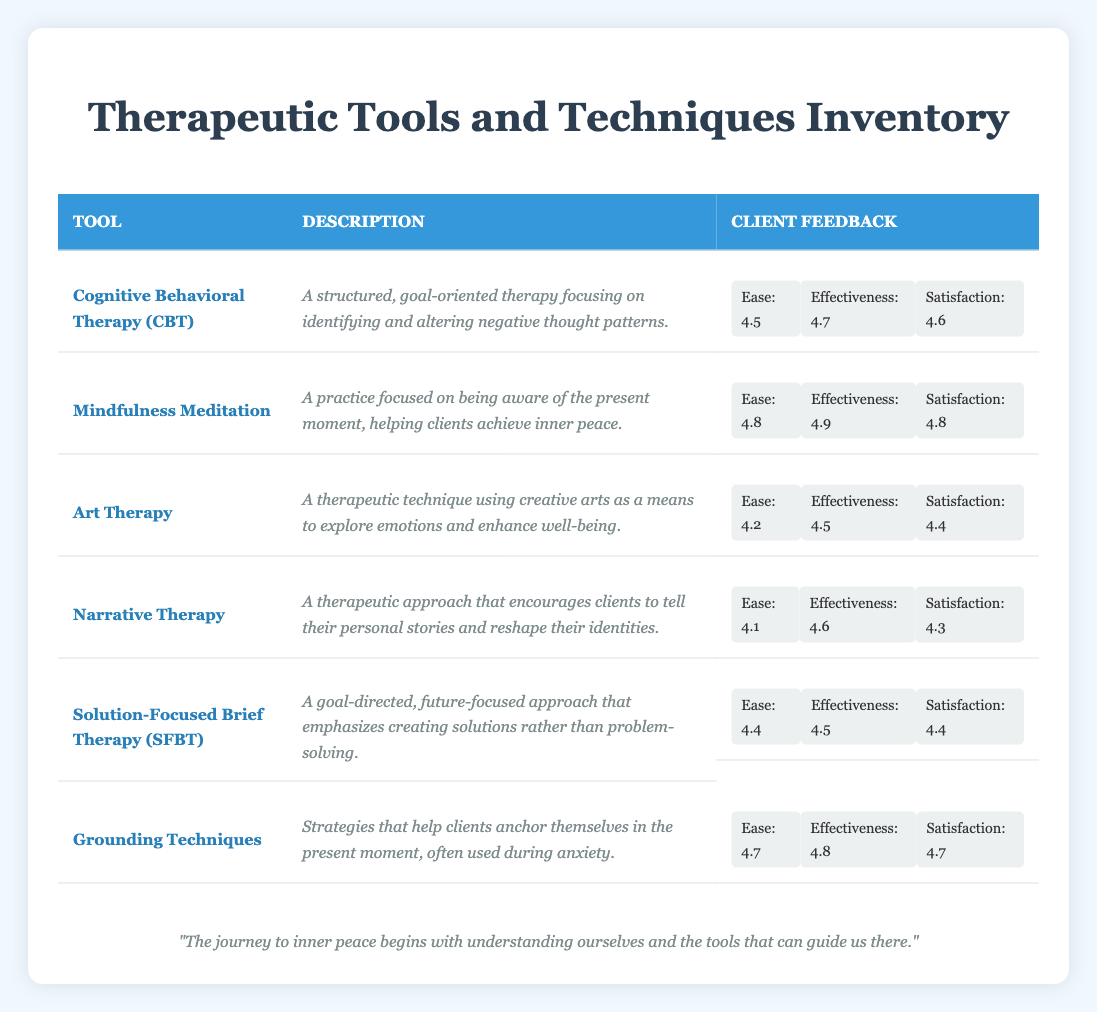What is the effectiveness score for Mindfulness Meditation? The effectiveness score for Mindfulness Meditation is 4.9, which can be found directly in the “Client Feedback” section of the table under that specific therapeutic tool.
Answer: 4.9 What technique has the lowest Ease of Use score? In the table, the Ease of Use scores for each tool are listed. The lowest score is 4.1, which is associated with Narrative Therapy.
Answer: Narrative Therapy What is the average Satisfaction score for the therapeutic tools listed? To find the average Satisfaction score, add the scores: (4.6 + 4.8 + 4.4 + 4.3 + 4.4 + 4.7) = 27.2. Then, divide by the number of tools (6): 27.2/6 = 4.53.
Answer: 4.53 Does Art Therapy have a higher effectiveness score than Narrative Therapy? The effectiveness score for Art Therapy is 4.5, while for Narrative Therapy, it is 4.6. Since 4.5 is less than 4.6, Art Therapy does not have a higher effectiveness score.
Answer: No Which therapeutic tool has the highest combined score of Ease of Use and Effectiveness? To find the highest combined score, calculate the sum for each tool. For instance, CBT: 4.5 + 4.7 = 9.2, Mindfulness Meditation: 4.8 + 4.9 = 9.7, Art Therapy: 4.2 + 4.5 = 8.7, Narrative Therapy: 4.1 + 4.6 = 8.7, SFBT: 4.4 + 4.5 = 8.9, Grounding Techniques: 4.7 + 4.8 = 9.5. Mindfulness Meditation has the highest combined score of 9.7.
Answer: Mindfulness Meditation Which technique scores highest in client feedback satisfaction, and what is that score? By comparing the Satisfaction scores listed for each therapeutic tool, Mindfulness Meditation has the highest score of 4.8.
Answer: Mindfulness Meditation, 4.8 